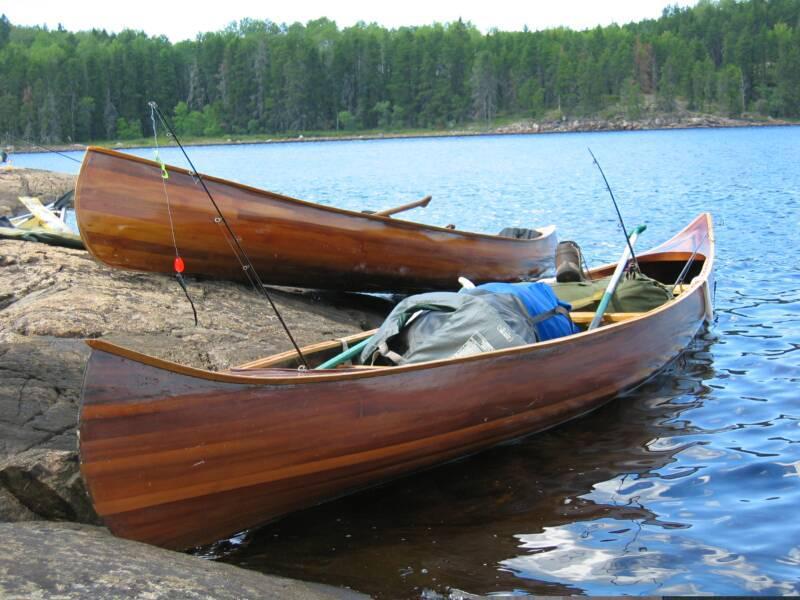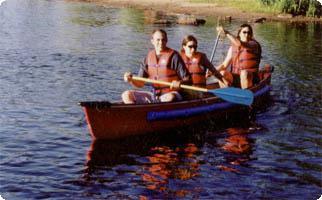The first image is the image on the left, the second image is the image on the right. Given the left and right images, does the statement "There is a child sitting between 2 adults in one of the images." hold true? Answer yes or no. No. The first image is the image on the left, the second image is the image on the right. Considering the images on both sides, is "Each canoe has three people sitting in them and at least two of those people have an oar." valid? Answer yes or no. No. 